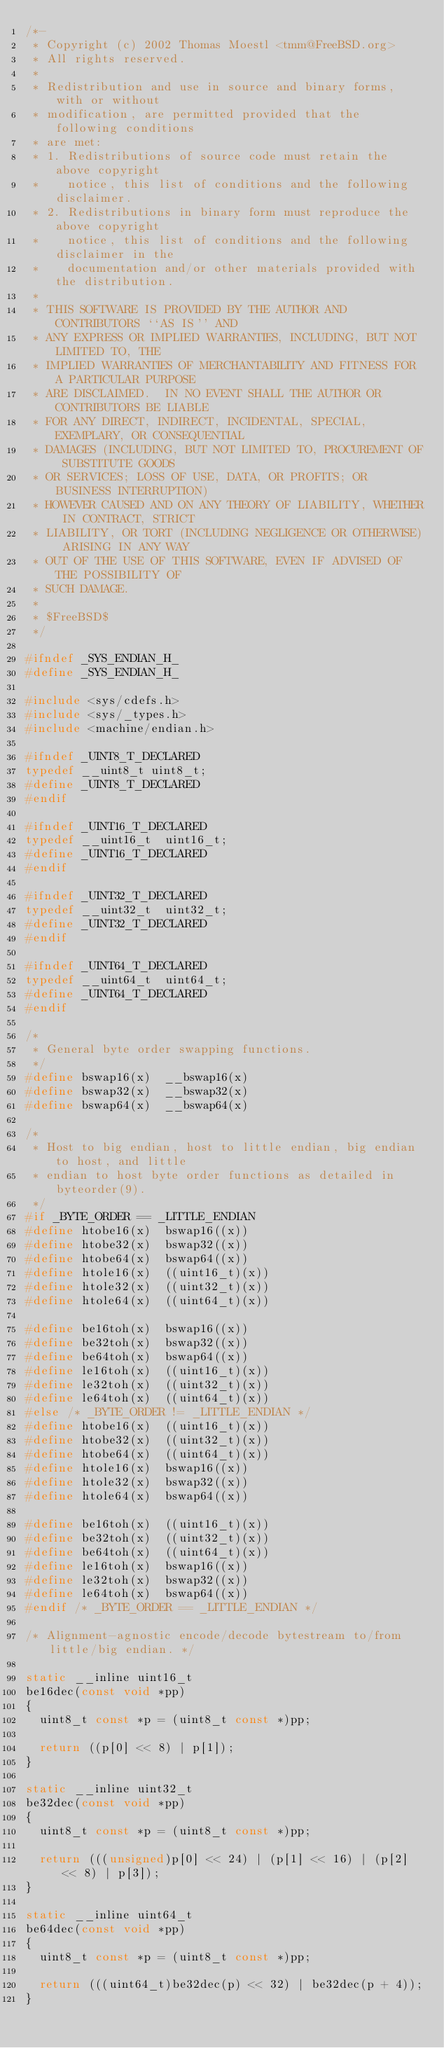<code> <loc_0><loc_0><loc_500><loc_500><_C_>/*-
 * Copyright (c) 2002 Thomas Moestl <tmm@FreeBSD.org>
 * All rights reserved.
 *
 * Redistribution and use in source and binary forms, with or without
 * modification, are permitted provided that the following conditions
 * are met:
 * 1. Redistributions of source code must retain the above copyright
 *    notice, this list of conditions and the following disclaimer.
 * 2. Redistributions in binary form must reproduce the above copyright
 *    notice, this list of conditions and the following disclaimer in the
 *    documentation and/or other materials provided with the distribution.
 *
 * THIS SOFTWARE IS PROVIDED BY THE AUTHOR AND CONTRIBUTORS ``AS IS'' AND
 * ANY EXPRESS OR IMPLIED WARRANTIES, INCLUDING, BUT NOT LIMITED TO, THE
 * IMPLIED WARRANTIES OF MERCHANTABILITY AND FITNESS FOR A PARTICULAR PURPOSE
 * ARE DISCLAIMED.  IN NO EVENT SHALL THE AUTHOR OR CONTRIBUTORS BE LIABLE
 * FOR ANY DIRECT, INDIRECT, INCIDENTAL, SPECIAL, EXEMPLARY, OR CONSEQUENTIAL
 * DAMAGES (INCLUDING, BUT NOT LIMITED TO, PROCUREMENT OF SUBSTITUTE GOODS
 * OR SERVICES; LOSS OF USE, DATA, OR PROFITS; OR BUSINESS INTERRUPTION)
 * HOWEVER CAUSED AND ON ANY THEORY OF LIABILITY, WHETHER IN CONTRACT, STRICT
 * LIABILITY, OR TORT (INCLUDING NEGLIGENCE OR OTHERWISE) ARISING IN ANY WAY
 * OUT OF THE USE OF THIS SOFTWARE, EVEN IF ADVISED OF THE POSSIBILITY OF
 * SUCH DAMAGE.
 *
 * $FreeBSD$
 */

#ifndef _SYS_ENDIAN_H_
#define _SYS_ENDIAN_H_

#include <sys/cdefs.h>
#include <sys/_types.h>
#include <machine/endian.h>

#ifndef _UINT8_T_DECLARED
typedef	__uint8_t	uint8_t;
#define	_UINT8_T_DECLARED
#endif
 
#ifndef _UINT16_T_DECLARED
typedef	__uint16_t	uint16_t;
#define	_UINT16_T_DECLARED
#endif
 
#ifndef _UINT32_T_DECLARED
typedef	__uint32_t	uint32_t;
#define	_UINT32_T_DECLARED
#endif
 
#ifndef _UINT64_T_DECLARED
typedef	__uint64_t	uint64_t;
#define	_UINT64_T_DECLARED
#endif
 
/*
 * General byte order swapping functions.
 */
#define	bswap16(x)	__bswap16(x)
#define	bswap32(x)	__bswap32(x)
#define	bswap64(x)	__bswap64(x)

/*
 * Host to big endian, host to little endian, big endian to host, and little
 * endian to host byte order functions as detailed in byteorder(9).
 */
#if _BYTE_ORDER == _LITTLE_ENDIAN
#define	htobe16(x)	bswap16((x))
#define	htobe32(x)	bswap32((x))
#define	htobe64(x)	bswap64((x))
#define	htole16(x)	((uint16_t)(x))
#define	htole32(x)	((uint32_t)(x))
#define	htole64(x)	((uint64_t)(x))

#define	be16toh(x)	bswap16((x))
#define	be32toh(x)	bswap32((x))
#define	be64toh(x)	bswap64((x))
#define	le16toh(x)	((uint16_t)(x))
#define	le32toh(x)	((uint32_t)(x))
#define	le64toh(x)	((uint64_t)(x))
#else /* _BYTE_ORDER != _LITTLE_ENDIAN */
#define	htobe16(x)	((uint16_t)(x))
#define	htobe32(x)	((uint32_t)(x))
#define	htobe64(x)	((uint64_t)(x))
#define	htole16(x)	bswap16((x))
#define	htole32(x)	bswap32((x))
#define	htole64(x)	bswap64((x))

#define	be16toh(x)	((uint16_t)(x))
#define	be32toh(x)	((uint32_t)(x))
#define	be64toh(x)	((uint64_t)(x))
#define	le16toh(x)	bswap16((x))
#define	le32toh(x)	bswap32((x))
#define	le64toh(x)	bswap64((x))
#endif /* _BYTE_ORDER == _LITTLE_ENDIAN */

/* Alignment-agnostic encode/decode bytestream to/from little/big endian. */

static __inline uint16_t
be16dec(const void *pp)
{
	uint8_t const *p = (uint8_t const *)pp;

	return ((p[0] << 8) | p[1]);
}

static __inline uint32_t
be32dec(const void *pp)
{
	uint8_t const *p = (uint8_t const *)pp;

	return (((unsigned)p[0] << 24) | (p[1] << 16) | (p[2] << 8) | p[3]);
}

static __inline uint64_t
be64dec(const void *pp)
{
	uint8_t const *p = (uint8_t const *)pp;

	return (((uint64_t)be32dec(p) << 32) | be32dec(p + 4));
}
</code> 